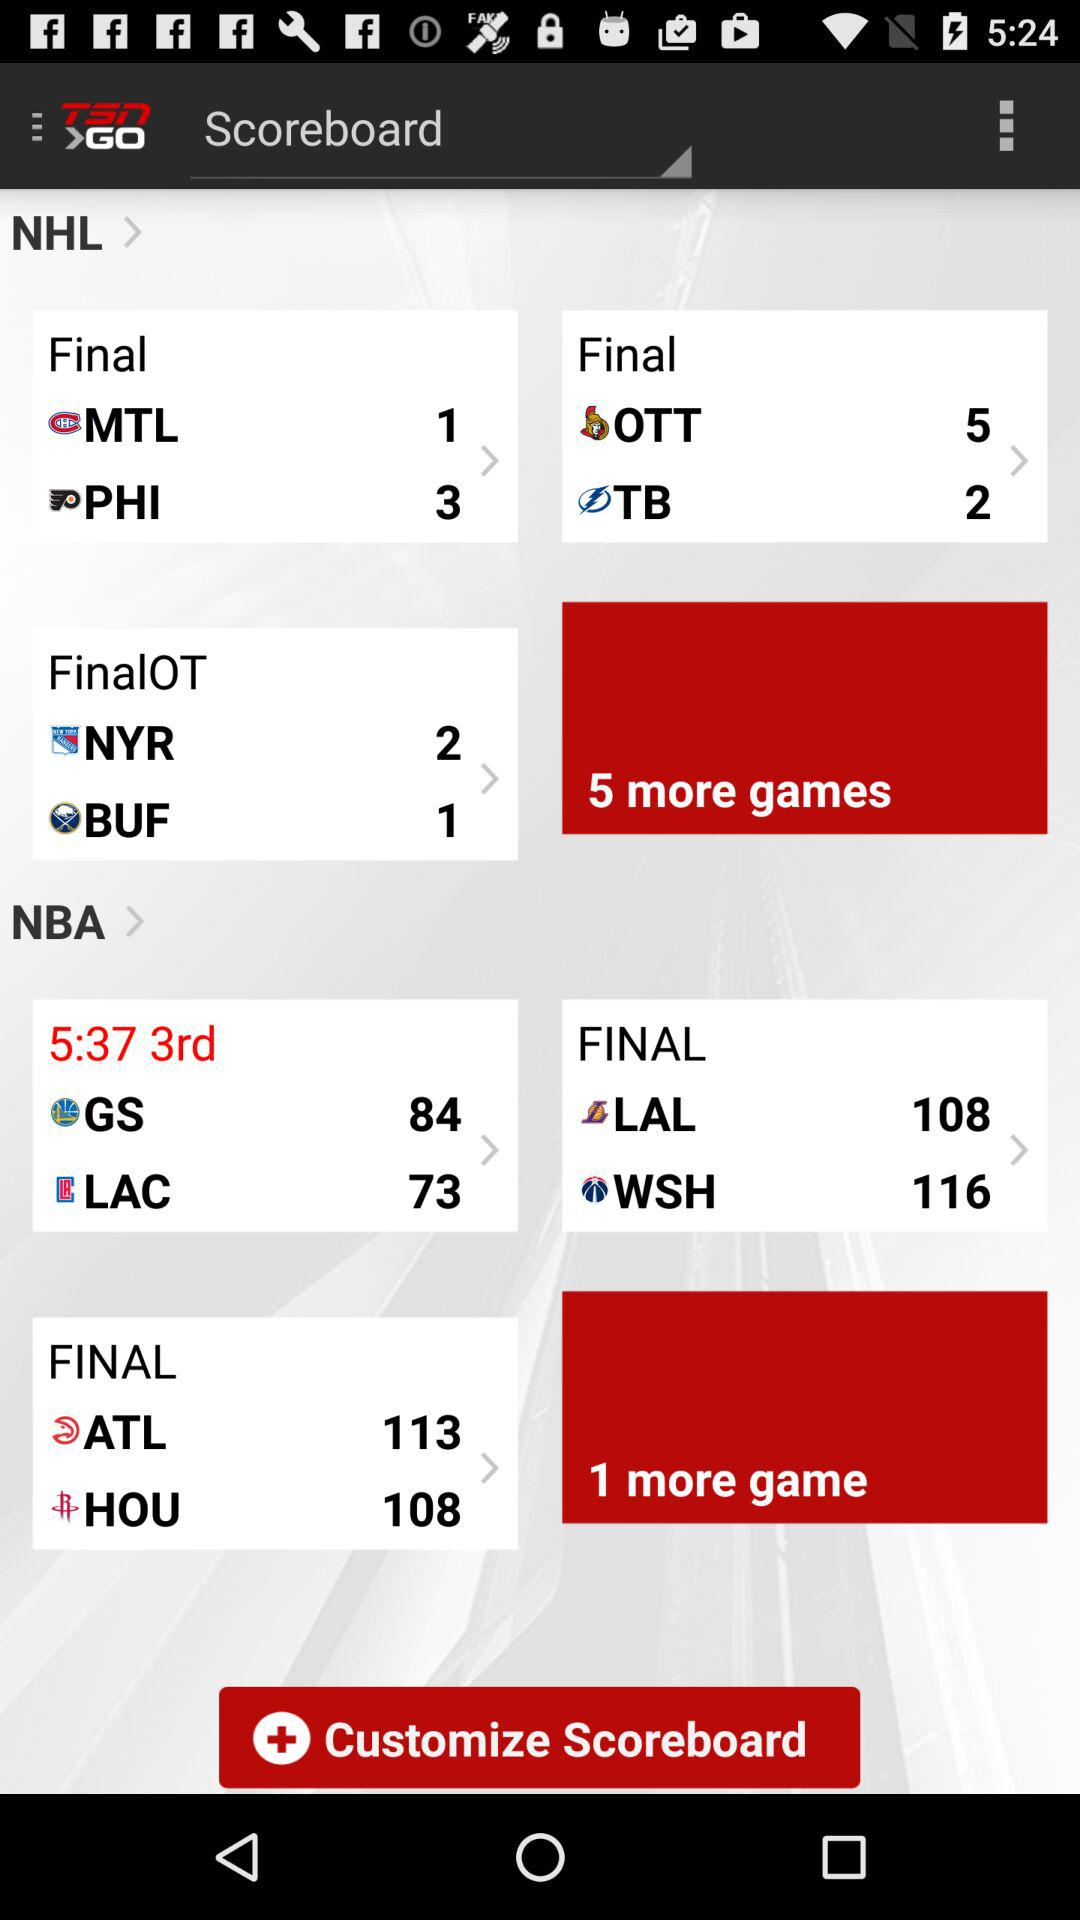What is the final score between MTL and PHI? The final scores between MTL and PHI are 1 and 3, respectively. 